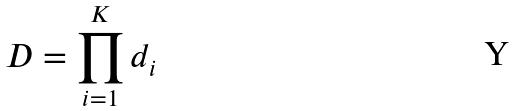Convert formula to latex. <formula><loc_0><loc_0><loc_500><loc_500>D = \prod _ { i = 1 } ^ { K } d _ { i }</formula> 